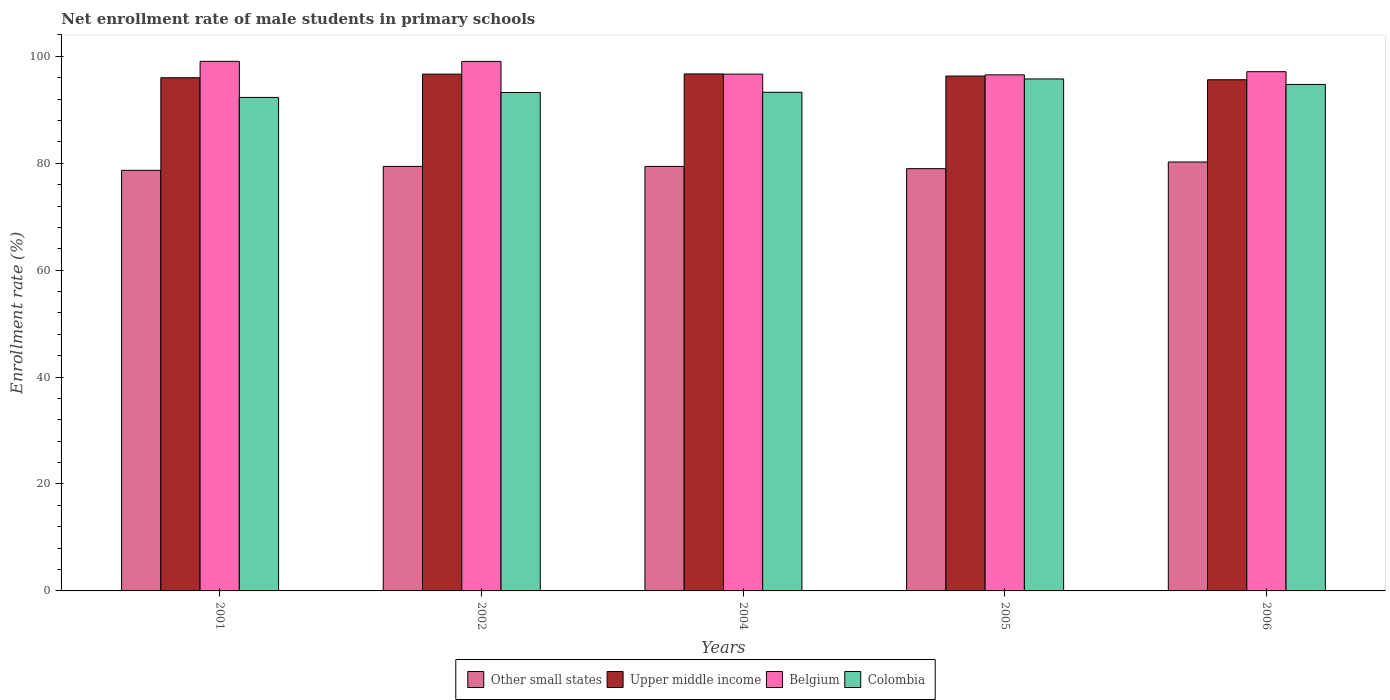How many groups of bars are there?
Keep it short and to the point. 5. Are the number of bars per tick equal to the number of legend labels?
Your answer should be very brief. Yes. Are the number of bars on each tick of the X-axis equal?
Keep it short and to the point. Yes. What is the label of the 3rd group of bars from the left?
Keep it short and to the point. 2004. What is the net enrollment rate of male students in primary schools in Other small states in 2006?
Your answer should be very brief. 80.23. Across all years, what is the maximum net enrollment rate of male students in primary schools in Upper middle income?
Your response must be concise. 96.7. Across all years, what is the minimum net enrollment rate of male students in primary schools in Upper middle income?
Your answer should be very brief. 95.62. In which year was the net enrollment rate of male students in primary schools in Belgium minimum?
Your response must be concise. 2005. What is the total net enrollment rate of male students in primary schools in Other small states in the graph?
Your response must be concise. 396.71. What is the difference between the net enrollment rate of male students in primary schools in Upper middle income in 2004 and that in 2005?
Your answer should be compact. 0.4. What is the difference between the net enrollment rate of male students in primary schools in Upper middle income in 2002 and the net enrollment rate of male students in primary schools in Other small states in 2004?
Give a very brief answer. 17.26. What is the average net enrollment rate of male students in primary schools in Upper middle income per year?
Offer a terse response. 96.26. In the year 2001, what is the difference between the net enrollment rate of male students in primary schools in Belgium and net enrollment rate of male students in primary schools in Other small states?
Ensure brevity in your answer.  20.38. What is the ratio of the net enrollment rate of male students in primary schools in Upper middle income in 2002 to that in 2004?
Your answer should be compact. 1. Is the net enrollment rate of male students in primary schools in Upper middle income in 2004 less than that in 2006?
Offer a very short reply. No. Is the difference between the net enrollment rate of male students in primary schools in Belgium in 2002 and 2005 greater than the difference between the net enrollment rate of male students in primary schools in Other small states in 2002 and 2005?
Offer a terse response. Yes. What is the difference between the highest and the second highest net enrollment rate of male students in primary schools in Colombia?
Your answer should be very brief. 1.03. What is the difference between the highest and the lowest net enrollment rate of male students in primary schools in Colombia?
Offer a very short reply. 3.45. In how many years, is the net enrollment rate of male students in primary schools in Other small states greater than the average net enrollment rate of male students in primary schools in Other small states taken over all years?
Your answer should be compact. 3. Is the sum of the net enrollment rate of male students in primary schools in Upper middle income in 2004 and 2005 greater than the maximum net enrollment rate of male students in primary schools in Other small states across all years?
Provide a succinct answer. Yes. Is it the case that in every year, the sum of the net enrollment rate of male students in primary schools in Colombia and net enrollment rate of male students in primary schools in Belgium is greater than the sum of net enrollment rate of male students in primary schools in Other small states and net enrollment rate of male students in primary schools in Upper middle income?
Ensure brevity in your answer.  Yes. What does the 1st bar from the left in 2004 represents?
Your answer should be compact. Other small states. Are all the bars in the graph horizontal?
Provide a succinct answer. No. What is the difference between two consecutive major ticks on the Y-axis?
Your answer should be compact. 20. Does the graph contain any zero values?
Provide a short and direct response. No. Where does the legend appear in the graph?
Offer a very short reply. Bottom center. What is the title of the graph?
Keep it short and to the point. Net enrollment rate of male students in primary schools. Does "Dominica" appear as one of the legend labels in the graph?
Make the answer very short. No. What is the label or title of the X-axis?
Ensure brevity in your answer.  Years. What is the label or title of the Y-axis?
Ensure brevity in your answer.  Enrollment rate (%). What is the Enrollment rate (%) in Other small states in 2001?
Your answer should be compact. 78.68. What is the Enrollment rate (%) of Upper middle income in 2001?
Your response must be concise. 95.99. What is the Enrollment rate (%) of Belgium in 2001?
Provide a succinct answer. 99.06. What is the Enrollment rate (%) in Colombia in 2001?
Make the answer very short. 92.31. What is the Enrollment rate (%) of Other small states in 2002?
Make the answer very short. 79.41. What is the Enrollment rate (%) in Upper middle income in 2002?
Give a very brief answer. 96.67. What is the Enrollment rate (%) of Belgium in 2002?
Offer a very short reply. 99.04. What is the Enrollment rate (%) of Colombia in 2002?
Give a very brief answer. 93.23. What is the Enrollment rate (%) of Other small states in 2004?
Provide a succinct answer. 79.41. What is the Enrollment rate (%) in Upper middle income in 2004?
Your answer should be very brief. 96.7. What is the Enrollment rate (%) in Belgium in 2004?
Your answer should be very brief. 96.67. What is the Enrollment rate (%) in Colombia in 2004?
Give a very brief answer. 93.27. What is the Enrollment rate (%) of Other small states in 2005?
Your answer should be very brief. 78.98. What is the Enrollment rate (%) of Upper middle income in 2005?
Give a very brief answer. 96.3. What is the Enrollment rate (%) in Belgium in 2005?
Give a very brief answer. 96.53. What is the Enrollment rate (%) of Colombia in 2005?
Offer a very short reply. 95.76. What is the Enrollment rate (%) in Other small states in 2006?
Your response must be concise. 80.23. What is the Enrollment rate (%) in Upper middle income in 2006?
Keep it short and to the point. 95.62. What is the Enrollment rate (%) in Belgium in 2006?
Ensure brevity in your answer.  97.12. What is the Enrollment rate (%) in Colombia in 2006?
Make the answer very short. 94.74. Across all years, what is the maximum Enrollment rate (%) of Other small states?
Your answer should be compact. 80.23. Across all years, what is the maximum Enrollment rate (%) of Upper middle income?
Give a very brief answer. 96.7. Across all years, what is the maximum Enrollment rate (%) of Belgium?
Your answer should be compact. 99.06. Across all years, what is the maximum Enrollment rate (%) in Colombia?
Your answer should be compact. 95.76. Across all years, what is the minimum Enrollment rate (%) of Other small states?
Make the answer very short. 78.68. Across all years, what is the minimum Enrollment rate (%) in Upper middle income?
Keep it short and to the point. 95.62. Across all years, what is the minimum Enrollment rate (%) of Belgium?
Make the answer very short. 96.53. Across all years, what is the minimum Enrollment rate (%) of Colombia?
Provide a succinct answer. 92.31. What is the total Enrollment rate (%) of Other small states in the graph?
Keep it short and to the point. 396.71. What is the total Enrollment rate (%) in Upper middle income in the graph?
Offer a terse response. 481.29. What is the total Enrollment rate (%) of Belgium in the graph?
Offer a terse response. 488.42. What is the total Enrollment rate (%) of Colombia in the graph?
Make the answer very short. 469.32. What is the difference between the Enrollment rate (%) in Other small states in 2001 and that in 2002?
Your answer should be compact. -0.73. What is the difference between the Enrollment rate (%) in Upper middle income in 2001 and that in 2002?
Offer a terse response. -0.68. What is the difference between the Enrollment rate (%) of Belgium in 2001 and that in 2002?
Make the answer very short. 0.01. What is the difference between the Enrollment rate (%) of Colombia in 2001 and that in 2002?
Give a very brief answer. -0.92. What is the difference between the Enrollment rate (%) of Other small states in 2001 and that in 2004?
Ensure brevity in your answer.  -0.73. What is the difference between the Enrollment rate (%) of Upper middle income in 2001 and that in 2004?
Offer a terse response. -0.71. What is the difference between the Enrollment rate (%) of Belgium in 2001 and that in 2004?
Offer a very short reply. 2.39. What is the difference between the Enrollment rate (%) of Colombia in 2001 and that in 2004?
Give a very brief answer. -0.96. What is the difference between the Enrollment rate (%) of Other small states in 2001 and that in 2005?
Your answer should be compact. -0.31. What is the difference between the Enrollment rate (%) of Upper middle income in 2001 and that in 2005?
Offer a terse response. -0.31. What is the difference between the Enrollment rate (%) in Belgium in 2001 and that in 2005?
Keep it short and to the point. 2.53. What is the difference between the Enrollment rate (%) of Colombia in 2001 and that in 2005?
Ensure brevity in your answer.  -3.45. What is the difference between the Enrollment rate (%) of Other small states in 2001 and that in 2006?
Your answer should be compact. -1.56. What is the difference between the Enrollment rate (%) in Upper middle income in 2001 and that in 2006?
Your answer should be compact. 0.38. What is the difference between the Enrollment rate (%) in Belgium in 2001 and that in 2006?
Your answer should be very brief. 1.93. What is the difference between the Enrollment rate (%) in Colombia in 2001 and that in 2006?
Offer a very short reply. -2.43. What is the difference between the Enrollment rate (%) of Other small states in 2002 and that in 2004?
Make the answer very short. -0. What is the difference between the Enrollment rate (%) in Upper middle income in 2002 and that in 2004?
Offer a very short reply. -0.04. What is the difference between the Enrollment rate (%) in Belgium in 2002 and that in 2004?
Your response must be concise. 2.38. What is the difference between the Enrollment rate (%) in Colombia in 2002 and that in 2004?
Provide a short and direct response. -0.05. What is the difference between the Enrollment rate (%) of Other small states in 2002 and that in 2005?
Keep it short and to the point. 0.42. What is the difference between the Enrollment rate (%) in Upper middle income in 2002 and that in 2005?
Offer a terse response. 0.36. What is the difference between the Enrollment rate (%) in Belgium in 2002 and that in 2005?
Your answer should be compact. 2.52. What is the difference between the Enrollment rate (%) of Colombia in 2002 and that in 2005?
Your answer should be very brief. -2.54. What is the difference between the Enrollment rate (%) in Other small states in 2002 and that in 2006?
Make the answer very short. -0.82. What is the difference between the Enrollment rate (%) of Upper middle income in 2002 and that in 2006?
Keep it short and to the point. 1.05. What is the difference between the Enrollment rate (%) in Belgium in 2002 and that in 2006?
Give a very brief answer. 1.92. What is the difference between the Enrollment rate (%) of Colombia in 2002 and that in 2006?
Keep it short and to the point. -1.51. What is the difference between the Enrollment rate (%) in Other small states in 2004 and that in 2005?
Your answer should be very brief. 0.42. What is the difference between the Enrollment rate (%) of Upper middle income in 2004 and that in 2005?
Offer a terse response. 0.4. What is the difference between the Enrollment rate (%) in Belgium in 2004 and that in 2005?
Keep it short and to the point. 0.14. What is the difference between the Enrollment rate (%) of Colombia in 2004 and that in 2005?
Give a very brief answer. -2.49. What is the difference between the Enrollment rate (%) of Other small states in 2004 and that in 2006?
Make the answer very short. -0.82. What is the difference between the Enrollment rate (%) of Upper middle income in 2004 and that in 2006?
Make the answer very short. 1.09. What is the difference between the Enrollment rate (%) in Belgium in 2004 and that in 2006?
Keep it short and to the point. -0.46. What is the difference between the Enrollment rate (%) in Colombia in 2004 and that in 2006?
Keep it short and to the point. -1.46. What is the difference between the Enrollment rate (%) in Other small states in 2005 and that in 2006?
Provide a short and direct response. -1.25. What is the difference between the Enrollment rate (%) of Upper middle income in 2005 and that in 2006?
Ensure brevity in your answer.  0.69. What is the difference between the Enrollment rate (%) of Belgium in 2005 and that in 2006?
Keep it short and to the point. -0.59. What is the difference between the Enrollment rate (%) in Colombia in 2005 and that in 2006?
Your answer should be very brief. 1.03. What is the difference between the Enrollment rate (%) in Other small states in 2001 and the Enrollment rate (%) in Upper middle income in 2002?
Offer a terse response. -17.99. What is the difference between the Enrollment rate (%) of Other small states in 2001 and the Enrollment rate (%) of Belgium in 2002?
Provide a short and direct response. -20.37. What is the difference between the Enrollment rate (%) in Other small states in 2001 and the Enrollment rate (%) in Colombia in 2002?
Offer a very short reply. -14.55. What is the difference between the Enrollment rate (%) of Upper middle income in 2001 and the Enrollment rate (%) of Belgium in 2002?
Give a very brief answer. -3.05. What is the difference between the Enrollment rate (%) in Upper middle income in 2001 and the Enrollment rate (%) in Colombia in 2002?
Make the answer very short. 2.76. What is the difference between the Enrollment rate (%) of Belgium in 2001 and the Enrollment rate (%) of Colombia in 2002?
Provide a succinct answer. 5.83. What is the difference between the Enrollment rate (%) in Other small states in 2001 and the Enrollment rate (%) in Upper middle income in 2004?
Provide a succinct answer. -18.03. What is the difference between the Enrollment rate (%) of Other small states in 2001 and the Enrollment rate (%) of Belgium in 2004?
Give a very brief answer. -17.99. What is the difference between the Enrollment rate (%) in Other small states in 2001 and the Enrollment rate (%) in Colombia in 2004?
Your answer should be compact. -14.6. What is the difference between the Enrollment rate (%) in Upper middle income in 2001 and the Enrollment rate (%) in Belgium in 2004?
Ensure brevity in your answer.  -0.67. What is the difference between the Enrollment rate (%) in Upper middle income in 2001 and the Enrollment rate (%) in Colombia in 2004?
Your answer should be very brief. 2.72. What is the difference between the Enrollment rate (%) of Belgium in 2001 and the Enrollment rate (%) of Colombia in 2004?
Keep it short and to the point. 5.78. What is the difference between the Enrollment rate (%) of Other small states in 2001 and the Enrollment rate (%) of Upper middle income in 2005?
Ensure brevity in your answer.  -17.63. What is the difference between the Enrollment rate (%) in Other small states in 2001 and the Enrollment rate (%) in Belgium in 2005?
Give a very brief answer. -17.85. What is the difference between the Enrollment rate (%) in Other small states in 2001 and the Enrollment rate (%) in Colombia in 2005?
Ensure brevity in your answer.  -17.09. What is the difference between the Enrollment rate (%) of Upper middle income in 2001 and the Enrollment rate (%) of Belgium in 2005?
Offer a very short reply. -0.54. What is the difference between the Enrollment rate (%) of Upper middle income in 2001 and the Enrollment rate (%) of Colombia in 2005?
Keep it short and to the point. 0.23. What is the difference between the Enrollment rate (%) of Belgium in 2001 and the Enrollment rate (%) of Colombia in 2005?
Keep it short and to the point. 3.29. What is the difference between the Enrollment rate (%) of Other small states in 2001 and the Enrollment rate (%) of Upper middle income in 2006?
Keep it short and to the point. -16.94. What is the difference between the Enrollment rate (%) of Other small states in 2001 and the Enrollment rate (%) of Belgium in 2006?
Give a very brief answer. -18.45. What is the difference between the Enrollment rate (%) in Other small states in 2001 and the Enrollment rate (%) in Colombia in 2006?
Your response must be concise. -16.06. What is the difference between the Enrollment rate (%) of Upper middle income in 2001 and the Enrollment rate (%) of Belgium in 2006?
Keep it short and to the point. -1.13. What is the difference between the Enrollment rate (%) of Upper middle income in 2001 and the Enrollment rate (%) of Colombia in 2006?
Your answer should be very brief. 1.25. What is the difference between the Enrollment rate (%) in Belgium in 2001 and the Enrollment rate (%) in Colombia in 2006?
Ensure brevity in your answer.  4.32. What is the difference between the Enrollment rate (%) in Other small states in 2002 and the Enrollment rate (%) in Upper middle income in 2004?
Your answer should be compact. -17.3. What is the difference between the Enrollment rate (%) in Other small states in 2002 and the Enrollment rate (%) in Belgium in 2004?
Give a very brief answer. -17.26. What is the difference between the Enrollment rate (%) of Other small states in 2002 and the Enrollment rate (%) of Colombia in 2004?
Keep it short and to the point. -13.87. What is the difference between the Enrollment rate (%) in Upper middle income in 2002 and the Enrollment rate (%) in Belgium in 2004?
Make the answer very short. 0. What is the difference between the Enrollment rate (%) in Upper middle income in 2002 and the Enrollment rate (%) in Colombia in 2004?
Keep it short and to the point. 3.39. What is the difference between the Enrollment rate (%) of Belgium in 2002 and the Enrollment rate (%) of Colombia in 2004?
Offer a terse response. 5.77. What is the difference between the Enrollment rate (%) of Other small states in 2002 and the Enrollment rate (%) of Upper middle income in 2005?
Your answer should be compact. -16.9. What is the difference between the Enrollment rate (%) of Other small states in 2002 and the Enrollment rate (%) of Belgium in 2005?
Ensure brevity in your answer.  -17.12. What is the difference between the Enrollment rate (%) of Other small states in 2002 and the Enrollment rate (%) of Colombia in 2005?
Keep it short and to the point. -16.36. What is the difference between the Enrollment rate (%) in Upper middle income in 2002 and the Enrollment rate (%) in Belgium in 2005?
Offer a very short reply. 0.14. What is the difference between the Enrollment rate (%) in Upper middle income in 2002 and the Enrollment rate (%) in Colombia in 2005?
Offer a terse response. 0.9. What is the difference between the Enrollment rate (%) in Belgium in 2002 and the Enrollment rate (%) in Colombia in 2005?
Make the answer very short. 3.28. What is the difference between the Enrollment rate (%) in Other small states in 2002 and the Enrollment rate (%) in Upper middle income in 2006?
Offer a very short reply. -16.21. What is the difference between the Enrollment rate (%) in Other small states in 2002 and the Enrollment rate (%) in Belgium in 2006?
Your response must be concise. -17.72. What is the difference between the Enrollment rate (%) of Other small states in 2002 and the Enrollment rate (%) of Colombia in 2006?
Ensure brevity in your answer.  -15.33. What is the difference between the Enrollment rate (%) of Upper middle income in 2002 and the Enrollment rate (%) of Belgium in 2006?
Offer a terse response. -0.45. What is the difference between the Enrollment rate (%) of Upper middle income in 2002 and the Enrollment rate (%) of Colombia in 2006?
Keep it short and to the point. 1.93. What is the difference between the Enrollment rate (%) in Belgium in 2002 and the Enrollment rate (%) in Colombia in 2006?
Provide a succinct answer. 4.31. What is the difference between the Enrollment rate (%) in Other small states in 2004 and the Enrollment rate (%) in Upper middle income in 2005?
Keep it short and to the point. -16.9. What is the difference between the Enrollment rate (%) of Other small states in 2004 and the Enrollment rate (%) of Belgium in 2005?
Offer a very short reply. -17.12. What is the difference between the Enrollment rate (%) of Other small states in 2004 and the Enrollment rate (%) of Colombia in 2005?
Your response must be concise. -16.36. What is the difference between the Enrollment rate (%) of Upper middle income in 2004 and the Enrollment rate (%) of Belgium in 2005?
Keep it short and to the point. 0.18. What is the difference between the Enrollment rate (%) in Belgium in 2004 and the Enrollment rate (%) in Colombia in 2005?
Your response must be concise. 0.9. What is the difference between the Enrollment rate (%) of Other small states in 2004 and the Enrollment rate (%) of Upper middle income in 2006?
Offer a terse response. -16.21. What is the difference between the Enrollment rate (%) in Other small states in 2004 and the Enrollment rate (%) in Belgium in 2006?
Your answer should be very brief. -17.71. What is the difference between the Enrollment rate (%) in Other small states in 2004 and the Enrollment rate (%) in Colombia in 2006?
Offer a terse response. -15.33. What is the difference between the Enrollment rate (%) of Upper middle income in 2004 and the Enrollment rate (%) of Belgium in 2006?
Your response must be concise. -0.42. What is the difference between the Enrollment rate (%) of Upper middle income in 2004 and the Enrollment rate (%) of Colombia in 2006?
Your response must be concise. 1.97. What is the difference between the Enrollment rate (%) in Belgium in 2004 and the Enrollment rate (%) in Colombia in 2006?
Give a very brief answer. 1.93. What is the difference between the Enrollment rate (%) of Other small states in 2005 and the Enrollment rate (%) of Upper middle income in 2006?
Give a very brief answer. -16.63. What is the difference between the Enrollment rate (%) of Other small states in 2005 and the Enrollment rate (%) of Belgium in 2006?
Your response must be concise. -18.14. What is the difference between the Enrollment rate (%) of Other small states in 2005 and the Enrollment rate (%) of Colombia in 2006?
Your response must be concise. -15.75. What is the difference between the Enrollment rate (%) in Upper middle income in 2005 and the Enrollment rate (%) in Belgium in 2006?
Provide a short and direct response. -0.82. What is the difference between the Enrollment rate (%) in Upper middle income in 2005 and the Enrollment rate (%) in Colombia in 2006?
Offer a terse response. 1.57. What is the difference between the Enrollment rate (%) in Belgium in 2005 and the Enrollment rate (%) in Colombia in 2006?
Offer a very short reply. 1.79. What is the average Enrollment rate (%) in Other small states per year?
Your answer should be compact. 79.34. What is the average Enrollment rate (%) in Upper middle income per year?
Make the answer very short. 96.26. What is the average Enrollment rate (%) of Belgium per year?
Offer a very short reply. 97.68. What is the average Enrollment rate (%) in Colombia per year?
Offer a very short reply. 93.86. In the year 2001, what is the difference between the Enrollment rate (%) of Other small states and Enrollment rate (%) of Upper middle income?
Provide a short and direct response. -17.32. In the year 2001, what is the difference between the Enrollment rate (%) of Other small states and Enrollment rate (%) of Belgium?
Provide a short and direct response. -20.38. In the year 2001, what is the difference between the Enrollment rate (%) in Other small states and Enrollment rate (%) in Colombia?
Your answer should be compact. -13.64. In the year 2001, what is the difference between the Enrollment rate (%) in Upper middle income and Enrollment rate (%) in Belgium?
Your response must be concise. -3.06. In the year 2001, what is the difference between the Enrollment rate (%) in Upper middle income and Enrollment rate (%) in Colombia?
Your answer should be compact. 3.68. In the year 2001, what is the difference between the Enrollment rate (%) in Belgium and Enrollment rate (%) in Colombia?
Offer a very short reply. 6.74. In the year 2002, what is the difference between the Enrollment rate (%) in Other small states and Enrollment rate (%) in Upper middle income?
Offer a terse response. -17.26. In the year 2002, what is the difference between the Enrollment rate (%) in Other small states and Enrollment rate (%) in Belgium?
Offer a terse response. -19.64. In the year 2002, what is the difference between the Enrollment rate (%) of Other small states and Enrollment rate (%) of Colombia?
Make the answer very short. -13.82. In the year 2002, what is the difference between the Enrollment rate (%) in Upper middle income and Enrollment rate (%) in Belgium?
Provide a succinct answer. -2.38. In the year 2002, what is the difference between the Enrollment rate (%) of Upper middle income and Enrollment rate (%) of Colombia?
Your response must be concise. 3.44. In the year 2002, what is the difference between the Enrollment rate (%) of Belgium and Enrollment rate (%) of Colombia?
Offer a terse response. 5.82. In the year 2004, what is the difference between the Enrollment rate (%) in Other small states and Enrollment rate (%) in Upper middle income?
Provide a short and direct response. -17.3. In the year 2004, what is the difference between the Enrollment rate (%) in Other small states and Enrollment rate (%) in Belgium?
Your answer should be very brief. -17.26. In the year 2004, what is the difference between the Enrollment rate (%) in Other small states and Enrollment rate (%) in Colombia?
Offer a terse response. -13.87. In the year 2004, what is the difference between the Enrollment rate (%) of Upper middle income and Enrollment rate (%) of Belgium?
Your answer should be very brief. 0.04. In the year 2004, what is the difference between the Enrollment rate (%) of Upper middle income and Enrollment rate (%) of Colombia?
Offer a terse response. 3.43. In the year 2004, what is the difference between the Enrollment rate (%) in Belgium and Enrollment rate (%) in Colombia?
Your response must be concise. 3.39. In the year 2005, what is the difference between the Enrollment rate (%) of Other small states and Enrollment rate (%) of Upper middle income?
Make the answer very short. -17.32. In the year 2005, what is the difference between the Enrollment rate (%) of Other small states and Enrollment rate (%) of Belgium?
Your response must be concise. -17.54. In the year 2005, what is the difference between the Enrollment rate (%) of Other small states and Enrollment rate (%) of Colombia?
Ensure brevity in your answer.  -16.78. In the year 2005, what is the difference between the Enrollment rate (%) in Upper middle income and Enrollment rate (%) in Belgium?
Provide a succinct answer. -0.23. In the year 2005, what is the difference between the Enrollment rate (%) in Upper middle income and Enrollment rate (%) in Colombia?
Ensure brevity in your answer.  0.54. In the year 2005, what is the difference between the Enrollment rate (%) of Belgium and Enrollment rate (%) of Colombia?
Make the answer very short. 0.76. In the year 2006, what is the difference between the Enrollment rate (%) of Other small states and Enrollment rate (%) of Upper middle income?
Ensure brevity in your answer.  -15.39. In the year 2006, what is the difference between the Enrollment rate (%) in Other small states and Enrollment rate (%) in Belgium?
Your response must be concise. -16.89. In the year 2006, what is the difference between the Enrollment rate (%) of Other small states and Enrollment rate (%) of Colombia?
Your answer should be compact. -14.51. In the year 2006, what is the difference between the Enrollment rate (%) in Upper middle income and Enrollment rate (%) in Belgium?
Offer a terse response. -1.51. In the year 2006, what is the difference between the Enrollment rate (%) of Upper middle income and Enrollment rate (%) of Colombia?
Your response must be concise. 0.88. In the year 2006, what is the difference between the Enrollment rate (%) in Belgium and Enrollment rate (%) in Colombia?
Provide a short and direct response. 2.38. What is the ratio of the Enrollment rate (%) of Other small states in 2001 to that in 2002?
Offer a terse response. 0.99. What is the ratio of the Enrollment rate (%) in Upper middle income in 2001 to that in 2002?
Give a very brief answer. 0.99. What is the ratio of the Enrollment rate (%) in Belgium in 2001 to that in 2002?
Provide a succinct answer. 1. What is the ratio of the Enrollment rate (%) in Colombia in 2001 to that in 2002?
Offer a very short reply. 0.99. What is the ratio of the Enrollment rate (%) in Upper middle income in 2001 to that in 2004?
Ensure brevity in your answer.  0.99. What is the ratio of the Enrollment rate (%) in Belgium in 2001 to that in 2004?
Offer a terse response. 1.02. What is the ratio of the Enrollment rate (%) in Belgium in 2001 to that in 2005?
Provide a short and direct response. 1.03. What is the ratio of the Enrollment rate (%) in Other small states in 2001 to that in 2006?
Offer a terse response. 0.98. What is the ratio of the Enrollment rate (%) in Belgium in 2001 to that in 2006?
Offer a terse response. 1.02. What is the ratio of the Enrollment rate (%) of Colombia in 2001 to that in 2006?
Offer a very short reply. 0.97. What is the ratio of the Enrollment rate (%) of Other small states in 2002 to that in 2004?
Your response must be concise. 1. What is the ratio of the Enrollment rate (%) of Upper middle income in 2002 to that in 2004?
Offer a very short reply. 1. What is the ratio of the Enrollment rate (%) in Belgium in 2002 to that in 2004?
Your response must be concise. 1.02. What is the ratio of the Enrollment rate (%) of Upper middle income in 2002 to that in 2005?
Give a very brief answer. 1. What is the ratio of the Enrollment rate (%) in Belgium in 2002 to that in 2005?
Provide a succinct answer. 1.03. What is the ratio of the Enrollment rate (%) in Colombia in 2002 to that in 2005?
Give a very brief answer. 0.97. What is the ratio of the Enrollment rate (%) in Belgium in 2002 to that in 2006?
Offer a terse response. 1.02. What is the ratio of the Enrollment rate (%) of Colombia in 2002 to that in 2006?
Provide a succinct answer. 0.98. What is the ratio of the Enrollment rate (%) of Other small states in 2004 to that in 2005?
Offer a very short reply. 1.01. What is the ratio of the Enrollment rate (%) of Belgium in 2004 to that in 2005?
Your answer should be very brief. 1. What is the ratio of the Enrollment rate (%) in Upper middle income in 2004 to that in 2006?
Ensure brevity in your answer.  1.01. What is the ratio of the Enrollment rate (%) in Colombia in 2004 to that in 2006?
Keep it short and to the point. 0.98. What is the ratio of the Enrollment rate (%) of Other small states in 2005 to that in 2006?
Your answer should be very brief. 0.98. What is the ratio of the Enrollment rate (%) of Upper middle income in 2005 to that in 2006?
Your response must be concise. 1.01. What is the ratio of the Enrollment rate (%) in Belgium in 2005 to that in 2006?
Your answer should be compact. 0.99. What is the ratio of the Enrollment rate (%) of Colombia in 2005 to that in 2006?
Your answer should be compact. 1.01. What is the difference between the highest and the second highest Enrollment rate (%) of Other small states?
Your answer should be compact. 0.82. What is the difference between the highest and the second highest Enrollment rate (%) in Upper middle income?
Your answer should be compact. 0.04. What is the difference between the highest and the second highest Enrollment rate (%) of Belgium?
Ensure brevity in your answer.  0.01. What is the difference between the highest and the second highest Enrollment rate (%) of Colombia?
Offer a terse response. 1.03. What is the difference between the highest and the lowest Enrollment rate (%) in Other small states?
Give a very brief answer. 1.56. What is the difference between the highest and the lowest Enrollment rate (%) of Upper middle income?
Your response must be concise. 1.09. What is the difference between the highest and the lowest Enrollment rate (%) in Belgium?
Ensure brevity in your answer.  2.53. What is the difference between the highest and the lowest Enrollment rate (%) in Colombia?
Your response must be concise. 3.45. 